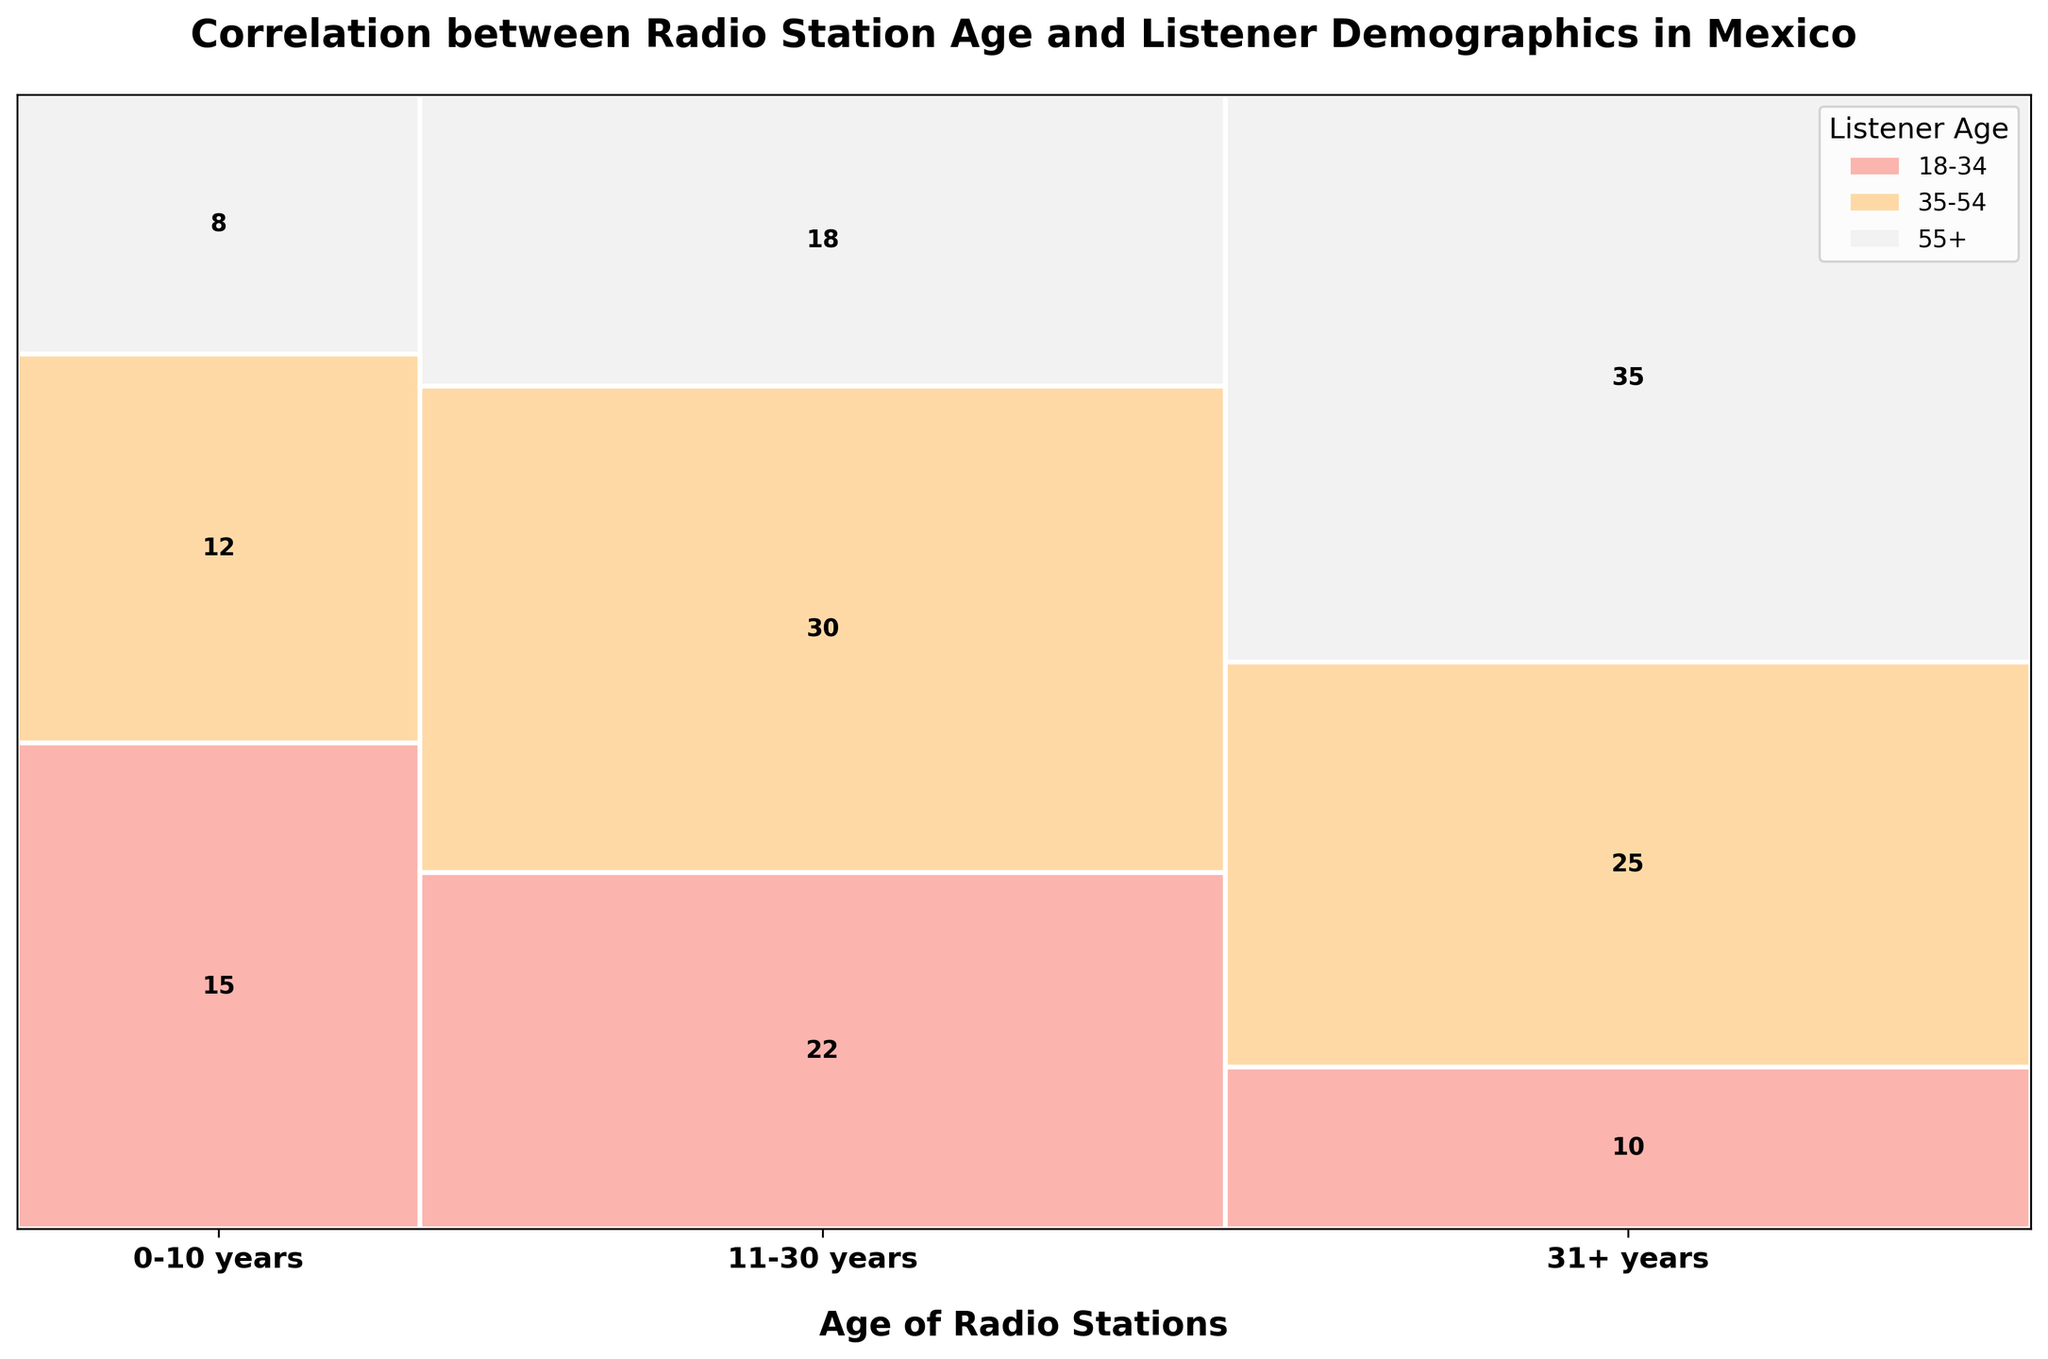What is the title of the plot? The title of the plot is usually located at the top and provides an overview of the plot's content. Here, it reads "Correlation between Radio Station Age and Listener Demographics in Mexico."
Answer: Correlation between Radio Station Age and Listener Demographics in Mexico How many total radio stations are there in the '0-10 years' age group? To find the total, add the station counts for the age group '0-10 years' across all listener age groups. That's 15 (18-34) + 12 (35-54) + 8 (55+).
Answer: 35 Which listener age group has the largest number of stations in the '31+ years' age group? Looking at the '31+ years' bands and comparing the heights, the '55+' group has the highest count. The exact count for '55+' is 35.
Answer: 55+ How does the number of stations targeting the 35-54 age group in the '11-30 years' compare to the '31+ years' group? In the '11-30 years' group, there are 30 stations targeting 35-54 listeners. In the '31+ years' group, there are 25 stations targeting this audience. Hence, the '11-30 years' group has 5 more stations.
Answer: 5 more in 11-30 years How many more stations target the 18-34 age group in the '11-30 years' category compared to '31+ years'? The plot shows 22 stations in the 18-34 age group for '11-30 years' and 10 for '31+ years'. The difference is 22 - 10.
Answer: 12 more What is the percentage of stations targeting 55+ listeners in the '31+ years' group? The total number of stations in the '31+ years' group is the sum of the counts for all listener groups: 10 + 25 + 35 = 70. The count for 55+ in the '31+ years' group is 35. So, (35/70) * 100 = 50%.
Answer: 50% How does the listener distribution for '11-30 years' radio stations appear in terms of percentages? Calculate the total stations for this age group, which is 22 + 30 + 18 = 70. The percentages are (22/70) * 100 for 18-34, (30/70) * 100 for 35-54, and (18/70) * 100 for 55+, which are approximately 31.4%, 42.9%, and 25.7% respectively.
Answer: 31.4%, 42.9%, 25.7% Which age group of radio stations has the smallest number of stations targeting the 35-54 age group? Viewing the plot, the '0-10 years' age group has the fewest stations (12) targeting the 35-54 age group compared to '11-30 years' and '31+ years'.
Answer: 0-10 years How does the number of stations with listeners aged 18-34 change as the age of the radio stations increases? When observing the plot, compare the counts for 18-34 listeners: 15 for '0-10 years', 22 for '11-30 years', and 10 for '31+ years'. There is an increase from '0-10' to '11-30', but a decrease from '11-30' to '31+'.
Answer: Increase then decrease What is the ratio of stations targeting 18-34 listeners in the '0-10 years' group to those in the '11-30 years' group? For '0-10 years' there are 15 stations for the 18-34 age group, and for '11-30 years' there are 22. The ratio is 15/22.
Answer: 15:22 